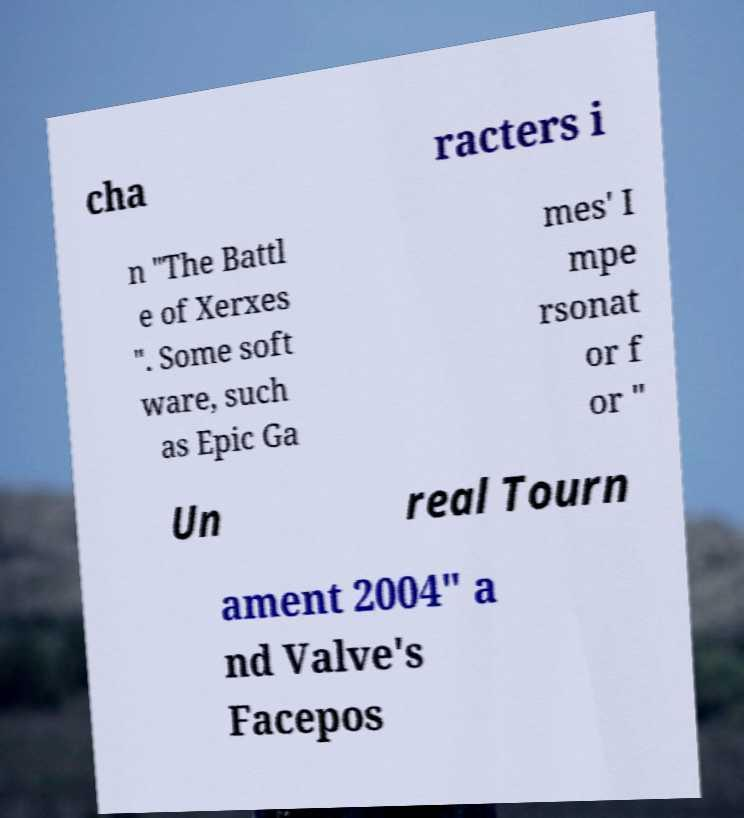Could you extract and type out the text from this image? cha racters i n "The Battl e of Xerxes ". Some soft ware, such as Epic Ga mes' I mpe rsonat or f or " Un real Tourn ament 2004" a nd Valve's Facepos 